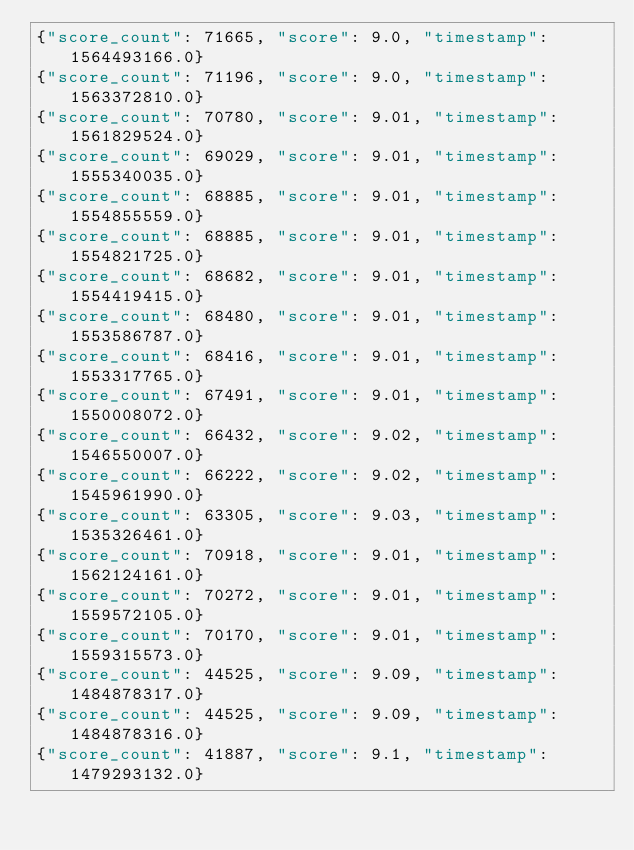Convert code to text. <code><loc_0><loc_0><loc_500><loc_500><_Julia_>{"score_count": 71665, "score": 9.0, "timestamp": 1564493166.0}
{"score_count": 71196, "score": 9.0, "timestamp": 1563372810.0}
{"score_count": 70780, "score": 9.01, "timestamp": 1561829524.0}
{"score_count": 69029, "score": 9.01, "timestamp": 1555340035.0}
{"score_count": 68885, "score": 9.01, "timestamp": 1554855559.0}
{"score_count": 68885, "score": 9.01, "timestamp": 1554821725.0}
{"score_count": 68682, "score": 9.01, "timestamp": 1554419415.0}
{"score_count": 68480, "score": 9.01, "timestamp": 1553586787.0}
{"score_count": 68416, "score": 9.01, "timestamp": 1553317765.0}
{"score_count": 67491, "score": 9.01, "timestamp": 1550008072.0}
{"score_count": 66432, "score": 9.02, "timestamp": 1546550007.0}
{"score_count": 66222, "score": 9.02, "timestamp": 1545961990.0}
{"score_count": 63305, "score": 9.03, "timestamp": 1535326461.0}
{"score_count": 70918, "score": 9.01, "timestamp": 1562124161.0}
{"score_count": 70272, "score": 9.01, "timestamp": 1559572105.0}
{"score_count": 70170, "score": 9.01, "timestamp": 1559315573.0}
{"score_count": 44525, "score": 9.09, "timestamp": 1484878317.0}
{"score_count": 44525, "score": 9.09, "timestamp": 1484878316.0}
{"score_count": 41887, "score": 9.1, "timestamp": 1479293132.0}
</code> 